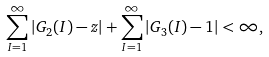Convert formula to latex. <formula><loc_0><loc_0><loc_500><loc_500>\sum _ { I = 1 } ^ { \infty } \left | G _ { 2 } ( I ) - z \right | + \sum _ { I = 1 } ^ { \infty } \left | G _ { 3 } ( I ) - 1 \right | < \infty ,</formula> 